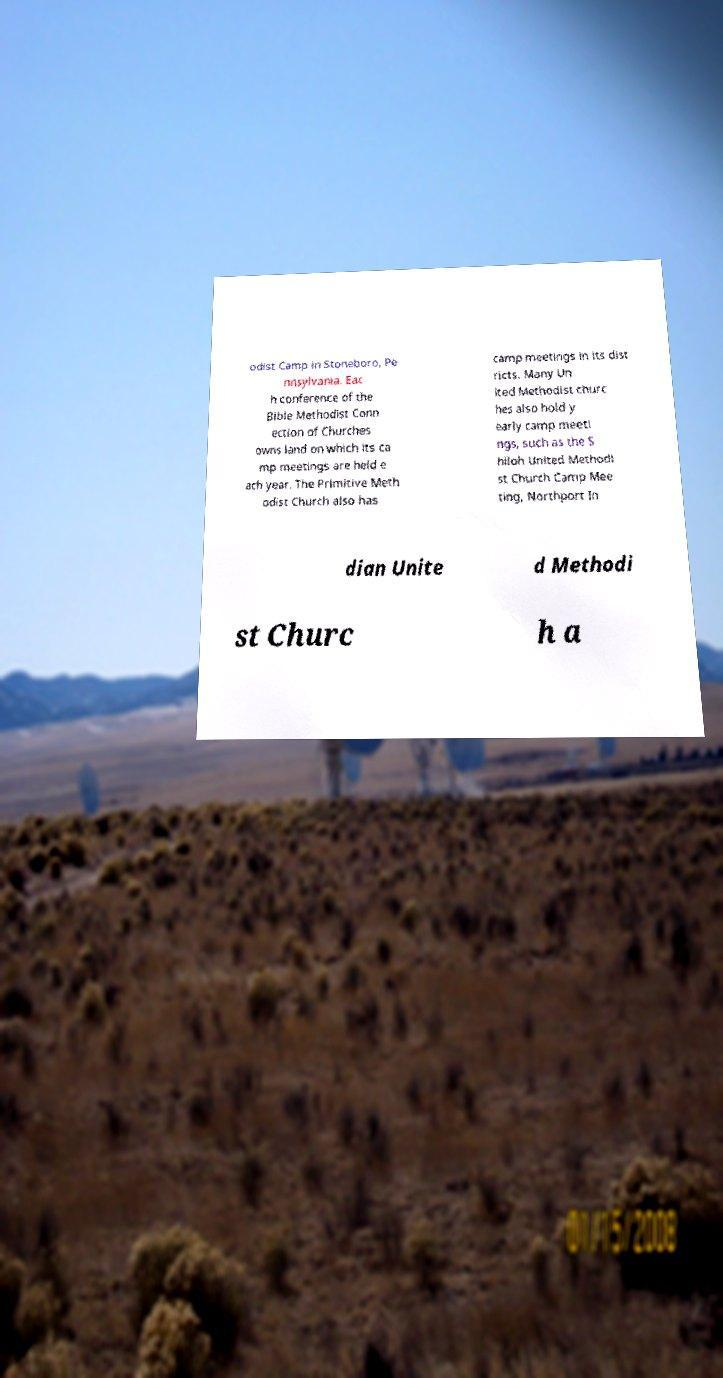Can you read and provide the text displayed in the image?This photo seems to have some interesting text. Can you extract and type it out for me? odist Camp in Stoneboro, Pe nnsylvania. Eac h conference of the Bible Methodist Conn ection of Churches owns land on which its ca mp meetings are held e ach year. The Primitive Meth odist Church also has camp meetings in its dist ricts. Many Un ited Methodist churc hes also hold y early camp meeti ngs, such as the S hiloh United Methodi st Church Camp Mee ting, Northport In dian Unite d Methodi st Churc h a 